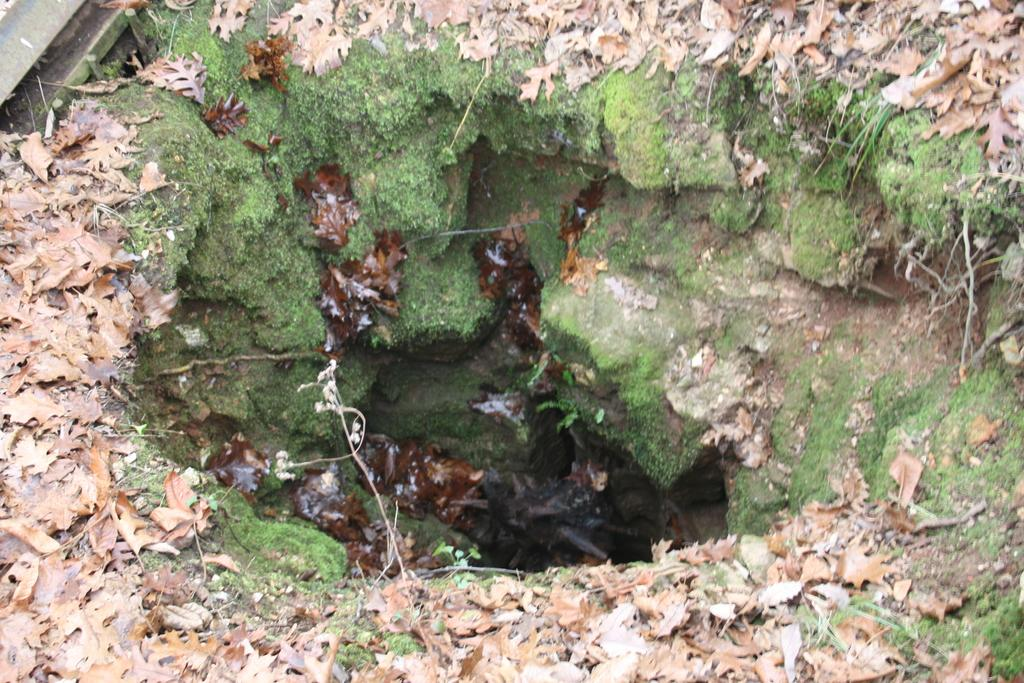What type of vegetation can be seen in the image? There are leaves in the image. What is the main feature in the middle of the image? There is a pit in the middle of the image. How many brothers are present in the image? There are no brothers mentioned or depicted in the image. What type of garden can be seen in the image? There is no garden present in the image; it only features leaves and a pit. 